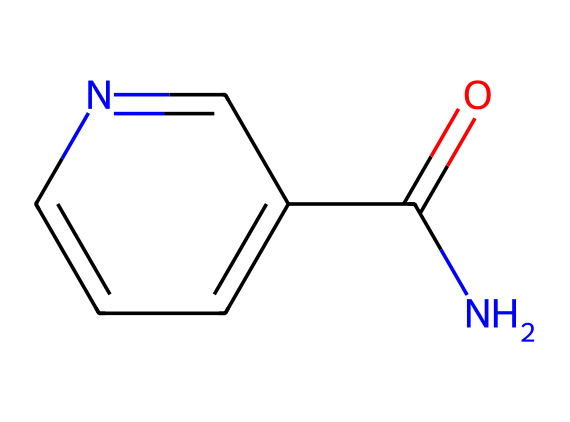What is the IUPAC name of this chemical? The chemical structure provided has an amide group (NC(=O)) attached to a pyridine ring (c1cccnc1). The IUPAC name for this structure is based on the presence of the amide functional group and the nitrogen-containing aromatic ring.
Answer: niacinamide How many nitrogen atoms are in this structure? By examining the chemical structure, we notice there are two nitrogen atoms: one in the amide group (NC) and one in the pyridine ring (c1cccnc1). It's common in nitrogen-containing compounds to have multiple nitrogen atoms contributing to different functionalities.
Answer: two What is the primary functional group in this compound? The presence of the amide group (NC(=O)) in this structure indicates that niacinamide has an amide functional group, which is pivotal for its chemical properties and activity in cosmetic formulations.
Answer: amide How many carbon atoms are present in the structure? Counting the carbon atoms, we see there are six: four in the aromatic ring, one in the amide group, and one implied in the carbonyl (C(=O)) of the amide.
Answer: six What is the role of niacinamide in cosmetic products? Niacinamide is known to enhance skin barrier function, improve skin tone, and reduce inflammation, thus being an essential ingredient in brightening serums. Its specific structure contributes to these beneficial properties.
Answer: skin brightening Is this compound polar or non-polar? Given the presence of an amide group and a pyridine ring, this compound exhibits polar characteristics because of the electronegative nitrogen and oxygen, which increase the overall polarity of the molecule.
Answer: polar 